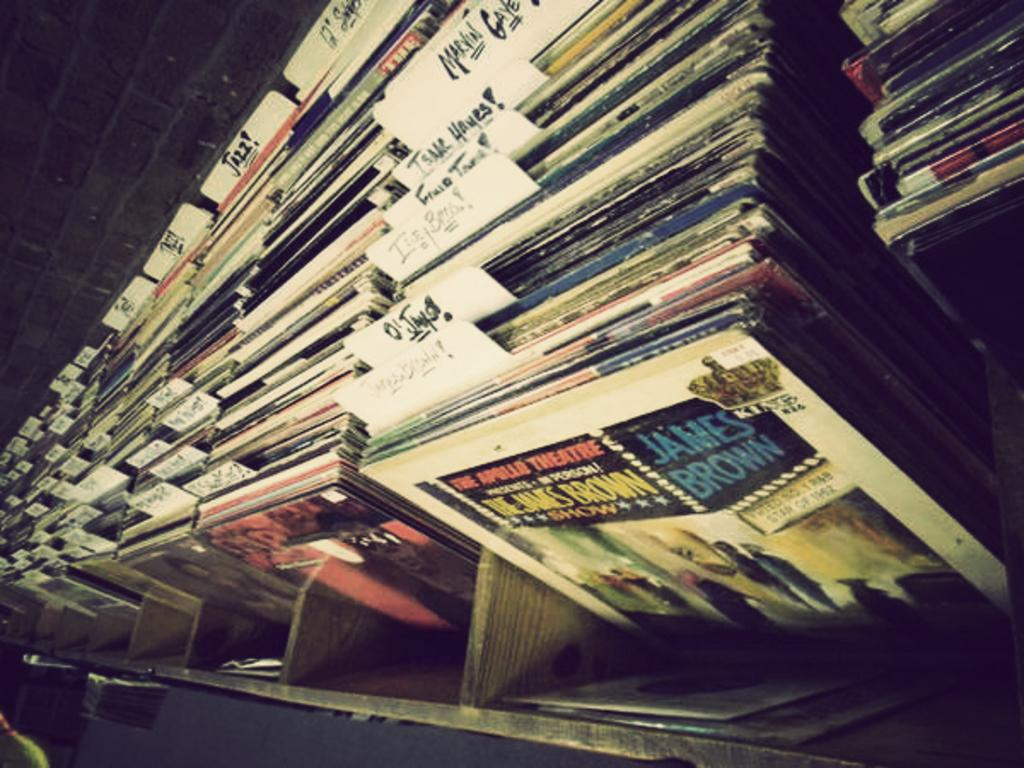Provide a one-sentence caption for the provided image. A stack of records has one by James Brown in front. 